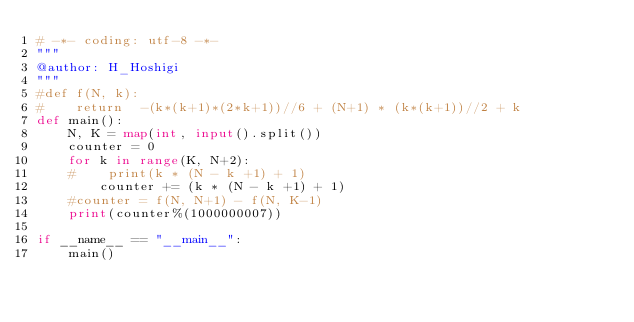Convert code to text. <code><loc_0><loc_0><loc_500><loc_500><_Python_># -*- coding: utf-8 -*-
"""
@author: H_Hoshigi
"""
#def f(N, k):
#    return  -(k*(k+1)*(2*k+1))//6 + (N+1) * (k*(k+1))//2 + k
def main():
    N, K = map(int, input().split())
    counter = 0
    for k in range(K, N+2):
    #    print(k * (N - k +1) + 1)
        counter += (k * (N - k +1) + 1)
    #counter = f(N, N+1) - f(N, K-1)
    print(counter%(1000000007))

if __name__ == "__main__":
    main()


</code> 